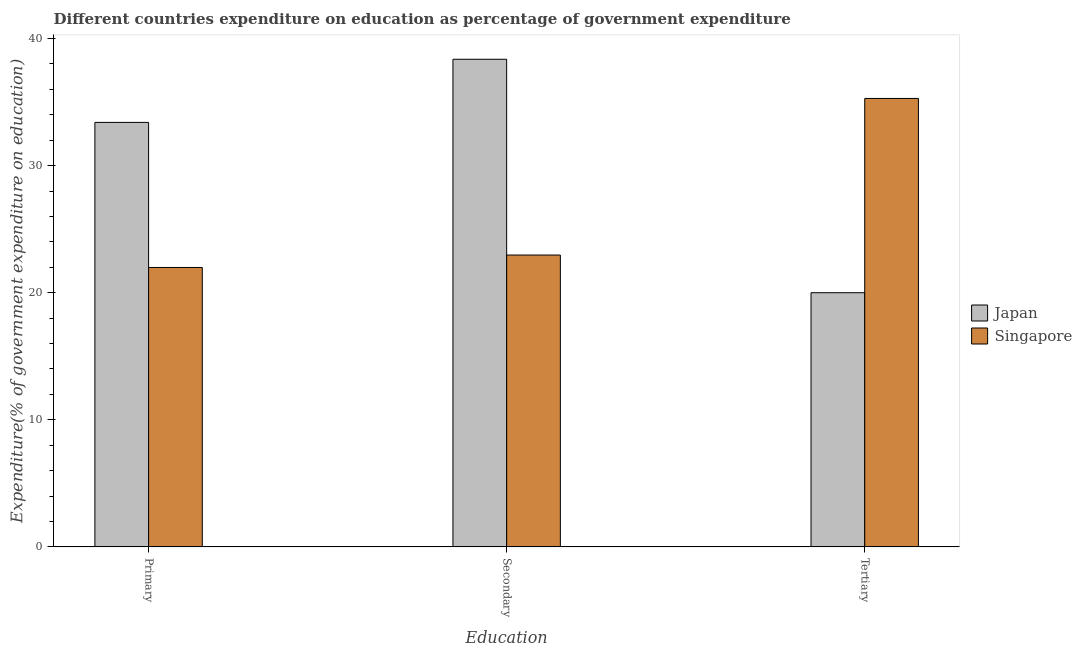How many groups of bars are there?
Make the answer very short. 3. Are the number of bars per tick equal to the number of legend labels?
Keep it short and to the point. Yes. How many bars are there on the 2nd tick from the left?
Make the answer very short. 2. How many bars are there on the 3rd tick from the right?
Your response must be concise. 2. What is the label of the 2nd group of bars from the left?
Ensure brevity in your answer.  Secondary. What is the expenditure on secondary education in Japan?
Offer a very short reply. 38.37. Across all countries, what is the maximum expenditure on secondary education?
Ensure brevity in your answer.  38.37. Across all countries, what is the minimum expenditure on primary education?
Give a very brief answer. 21.98. In which country was the expenditure on primary education maximum?
Provide a short and direct response. Japan. In which country was the expenditure on tertiary education minimum?
Your answer should be compact. Japan. What is the total expenditure on secondary education in the graph?
Your answer should be very brief. 61.33. What is the difference between the expenditure on primary education in Japan and that in Singapore?
Provide a succinct answer. 11.42. What is the difference between the expenditure on tertiary education in Singapore and the expenditure on primary education in Japan?
Keep it short and to the point. 1.88. What is the average expenditure on tertiary education per country?
Your answer should be very brief. 27.64. What is the difference between the expenditure on secondary education and expenditure on tertiary education in Japan?
Keep it short and to the point. 18.37. What is the ratio of the expenditure on secondary education in Singapore to that in Japan?
Give a very brief answer. 0.6. Is the expenditure on tertiary education in Japan less than that in Singapore?
Your answer should be very brief. Yes. Is the difference between the expenditure on tertiary education in Japan and Singapore greater than the difference between the expenditure on primary education in Japan and Singapore?
Provide a short and direct response. No. What is the difference between the highest and the second highest expenditure on secondary education?
Make the answer very short. 15.41. What is the difference between the highest and the lowest expenditure on primary education?
Offer a terse response. 11.42. In how many countries, is the expenditure on primary education greater than the average expenditure on primary education taken over all countries?
Make the answer very short. 1. What does the 2nd bar from the right in Primary represents?
Provide a short and direct response. Japan. Are all the bars in the graph horizontal?
Keep it short and to the point. No. How many countries are there in the graph?
Your response must be concise. 2. Are the values on the major ticks of Y-axis written in scientific E-notation?
Provide a short and direct response. No. Does the graph contain grids?
Keep it short and to the point. No. How are the legend labels stacked?
Keep it short and to the point. Vertical. What is the title of the graph?
Ensure brevity in your answer.  Different countries expenditure on education as percentage of government expenditure. Does "Marshall Islands" appear as one of the legend labels in the graph?
Keep it short and to the point. No. What is the label or title of the X-axis?
Offer a terse response. Education. What is the label or title of the Y-axis?
Offer a terse response. Expenditure(% of government expenditure on education). What is the Expenditure(% of government expenditure on education) in Japan in Primary?
Ensure brevity in your answer.  33.4. What is the Expenditure(% of government expenditure on education) in Singapore in Primary?
Ensure brevity in your answer.  21.98. What is the Expenditure(% of government expenditure on education) in Japan in Secondary?
Your answer should be compact. 38.37. What is the Expenditure(% of government expenditure on education) of Singapore in Secondary?
Offer a very short reply. 22.96. What is the Expenditure(% of government expenditure on education) in Japan in Tertiary?
Your answer should be compact. 20. What is the Expenditure(% of government expenditure on education) of Singapore in Tertiary?
Offer a very short reply. 35.28. Across all Education, what is the maximum Expenditure(% of government expenditure on education) of Japan?
Provide a short and direct response. 38.37. Across all Education, what is the maximum Expenditure(% of government expenditure on education) in Singapore?
Give a very brief answer. 35.28. Across all Education, what is the minimum Expenditure(% of government expenditure on education) in Japan?
Provide a succinct answer. 20. Across all Education, what is the minimum Expenditure(% of government expenditure on education) of Singapore?
Keep it short and to the point. 21.98. What is the total Expenditure(% of government expenditure on education) in Japan in the graph?
Your answer should be very brief. 91.76. What is the total Expenditure(% of government expenditure on education) of Singapore in the graph?
Keep it short and to the point. 80.23. What is the difference between the Expenditure(% of government expenditure on education) of Japan in Primary and that in Secondary?
Your answer should be very brief. -4.97. What is the difference between the Expenditure(% of government expenditure on education) of Singapore in Primary and that in Secondary?
Your response must be concise. -0.98. What is the difference between the Expenditure(% of government expenditure on education) in Japan in Primary and that in Tertiary?
Your answer should be very brief. 13.4. What is the difference between the Expenditure(% of government expenditure on education) of Singapore in Primary and that in Tertiary?
Give a very brief answer. -13.3. What is the difference between the Expenditure(% of government expenditure on education) of Japan in Secondary and that in Tertiary?
Make the answer very short. 18.37. What is the difference between the Expenditure(% of government expenditure on education) of Singapore in Secondary and that in Tertiary?
Keep it short and to the point. -12.32. What is the difference between the Expenditure(% of government expenditure on education) in Japan in Primary and the Expenditure(% of government expenditure on education) in Singapore in Secondary?
Keep it short and to the point. 10.44. What is the difference between the Expenditure(% of government expenditure on education) in Japan in Primary and the Expenditure(% of government expenditure on education) in Singapore in Tertiary?
Provide a short and direct response. -1.88. What is the difference between the Expenditure(% of government expenditure on education) of Japan in Secondary and the Expenditure(% of government expenditure on education) of Singapore in Tertiary?
Offer a terse response. 3.08. What is the average Expenditure(% of government expenditure on education) of Japan per Education?
Offer a very short reply. 30.59. What is the average Expenditure(% of government expenditure on education) in Singapore per Education?
Your answer should be very brief. 26.74. What is the difference between the Expenditure(% of government expenditure on education) in Japan and Expenditure(% of government expenditure on education) in Singapore in Primary?
Make the answer very short. 11.42. What is the difference between the Expenditure(% of government expenditure on education) of Japan and Expenditure(% of government expenditure on education) of Singapore in Secondary?
Your response must be concise. 15.41. What is the difference between the Expenditure(% of government expenditure on education) of Japan and Expenditure(% of government expenditure on education) of Singapore in Tertiary?
Make the answer very short. -15.29. What is the ratio of the Expenditure(% of government expenditure on education) of Japan in Primary to that in Secondary?
Provide a short and direct response. 0.87. What is the ratio of the Expenditure(% of government expenditure on education) in Singapore in Primary to that in Secondary?
Keep it short and to the point. 0.96. What is the ratio of the Expenditure(% of government expenditure on education) of Japan in Primary to that in Tertiary?
Provide a short and direct response. 1.67. What is the ratio of the Expenditure(% of government expenditure on education) in Singapore in Primary to that in Tertiary?
Your response must be concise. 0.62. What is the ratio of the Expenditure(% of government expenditure on education) in Japan in Secondary to that in Tertiary?
Offer a terse response. 1.92. What is the ratio of the Expenditure(% of government expenditure on education) in Singapore in Secondary to that in Tertiary?
Provide a short and direct response. 0.65. What is the difference between the highest and the second highest Expenditure(% of government expenditure on education) in Japan?
Keep it short and to the point. 4.97. What is the difference between the highest and the second highest Expenditure(% of government expenditure on education) of Singapore?
Give a very brief answer. 12.32. What is the difference between the highest and the lowest Expenditure(% of government expenditure on education) in Japan?
Provide a succinct answer. 18.37. What is the difference between the highest and the lowest Expenditure(% of government expenditure on education) of Singapore?
Give a very brief answer. 13.3. 